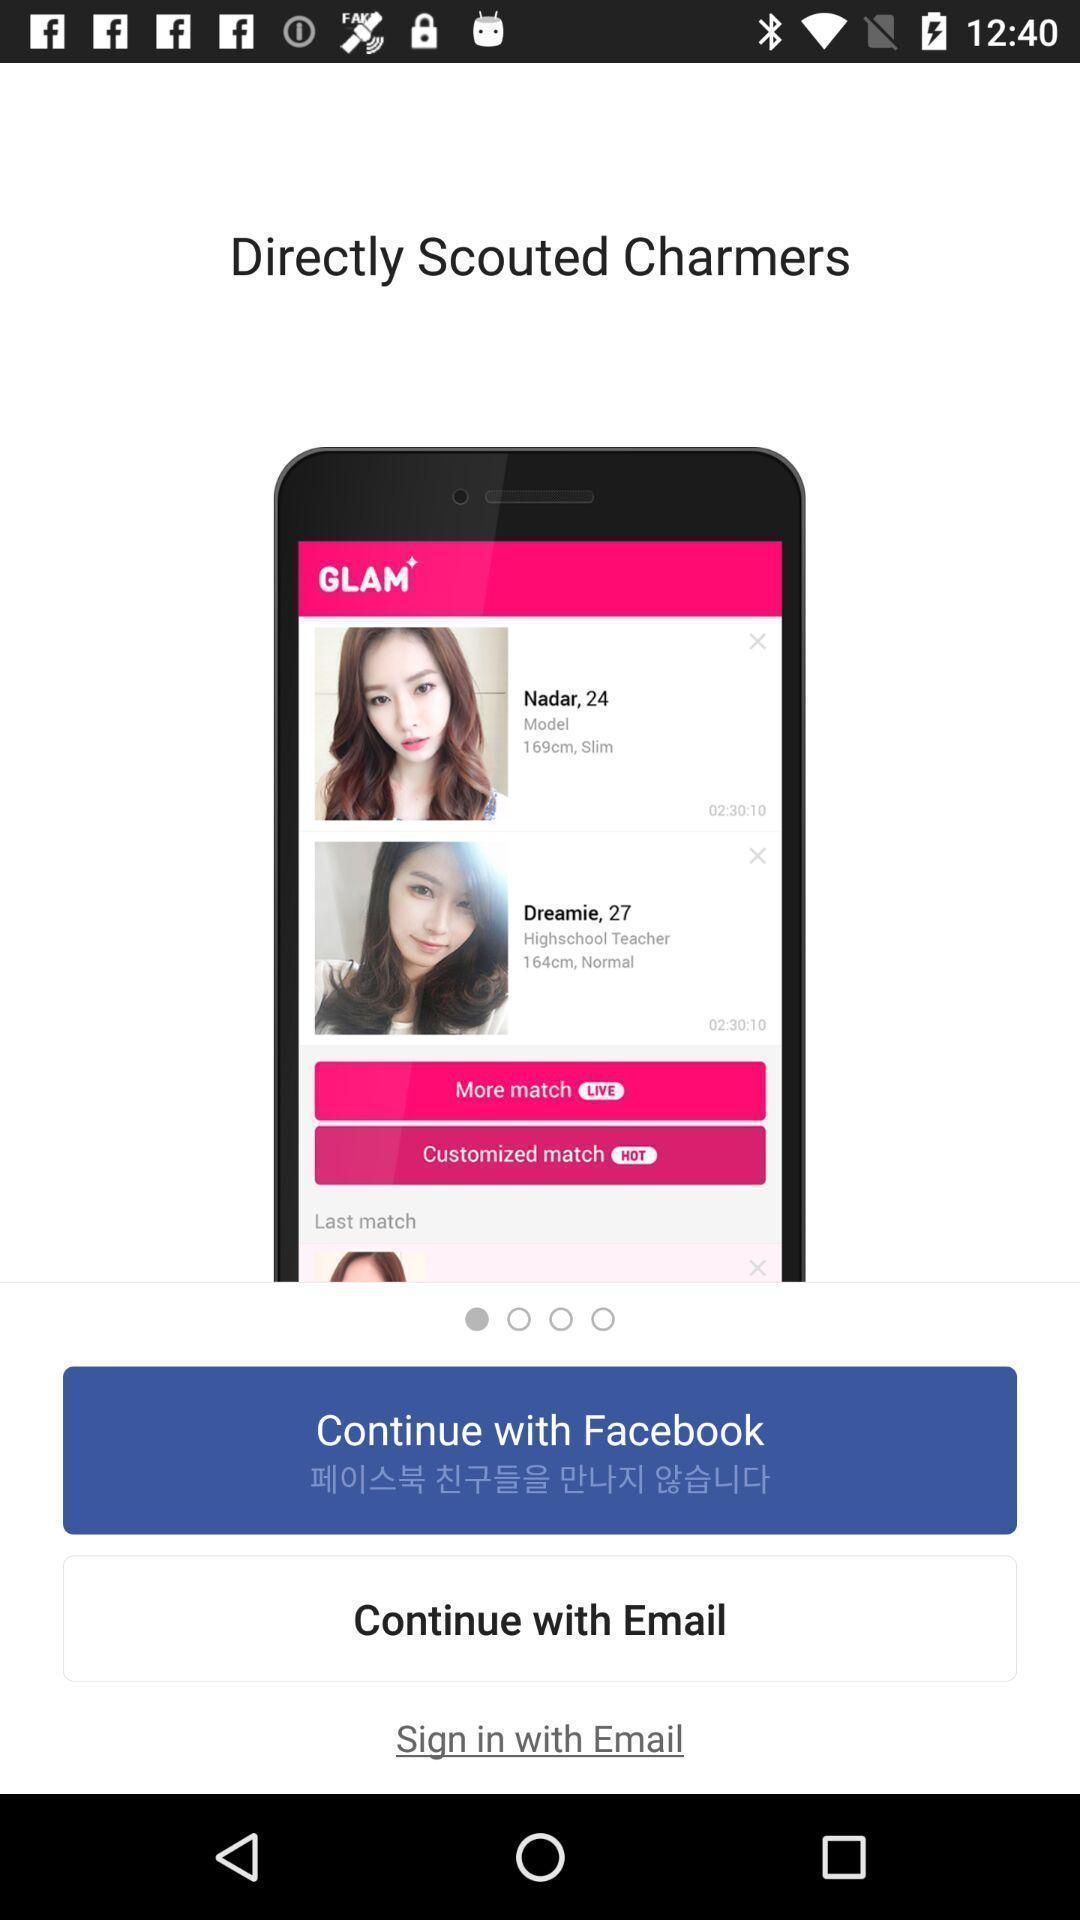Explain what's happening in this screen capture. Sign in page of a dating app. 